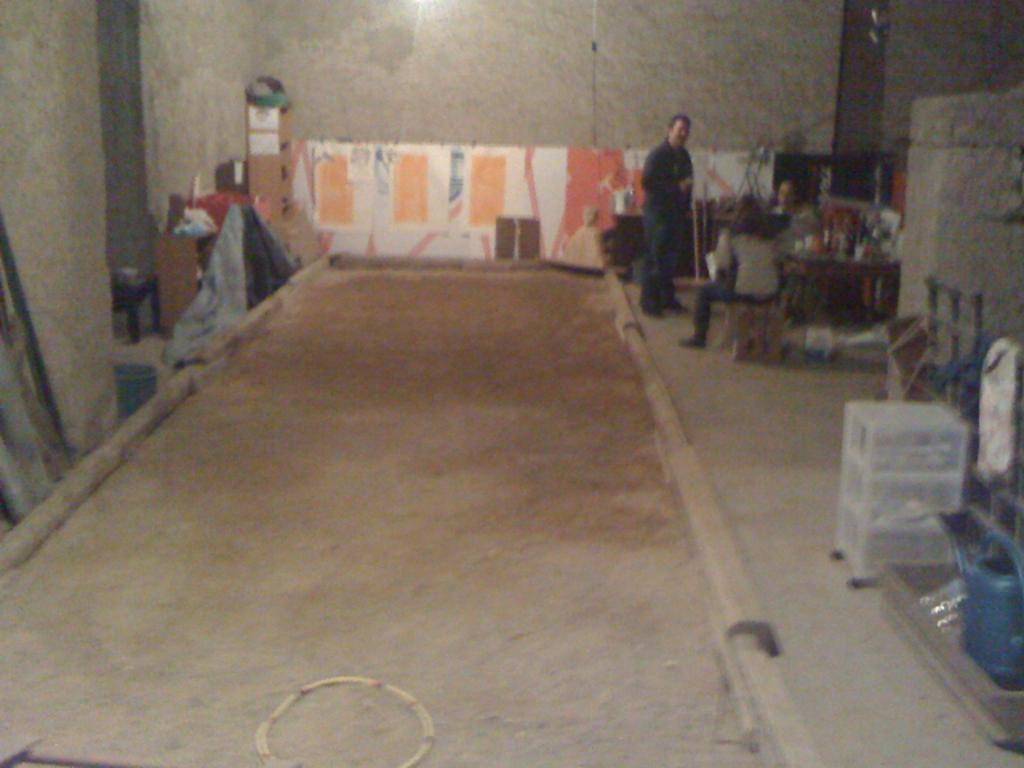Can you describe this image briefly? In this picture we can see small ground in the front/. Behind there is a man standing and looking into the camera and some canvas posters. On the right side there are is tool box. Behind there is a brown wall. 